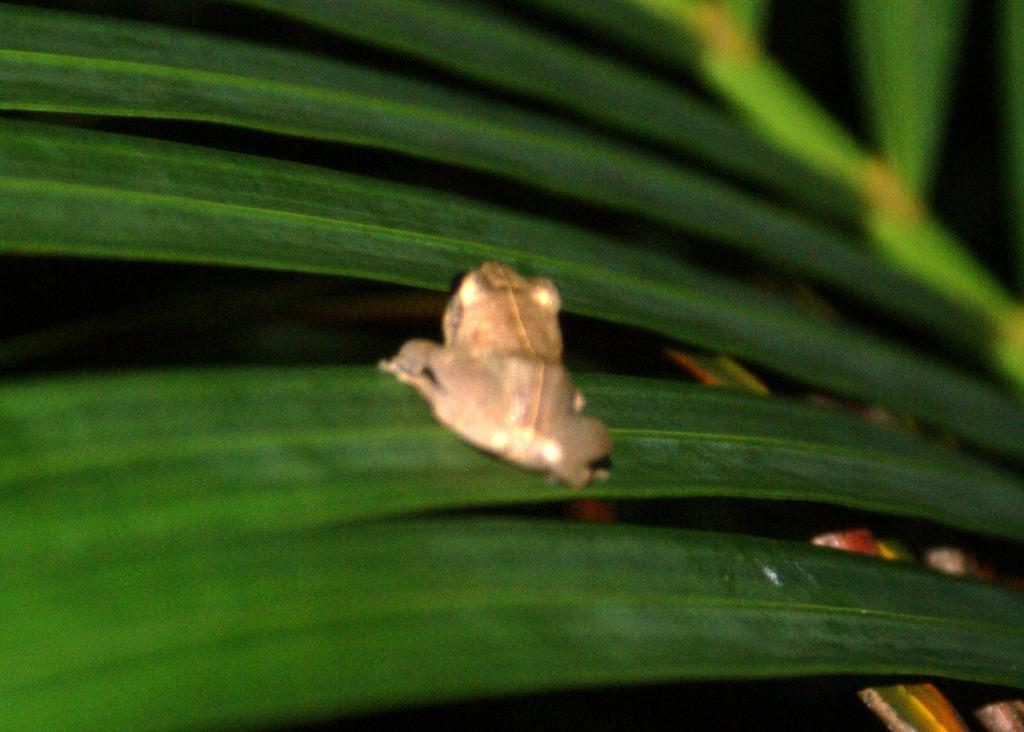What type of animal is present in the image? There is a frog in the image. What other objects or elements can be seen in the image? There are leaves in the image. What type of cap is the frog wearing in the image? There is no cap present in the image, as the frog is not wearing any clothing or accessories. 